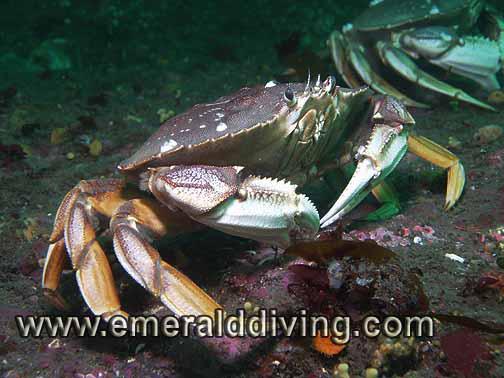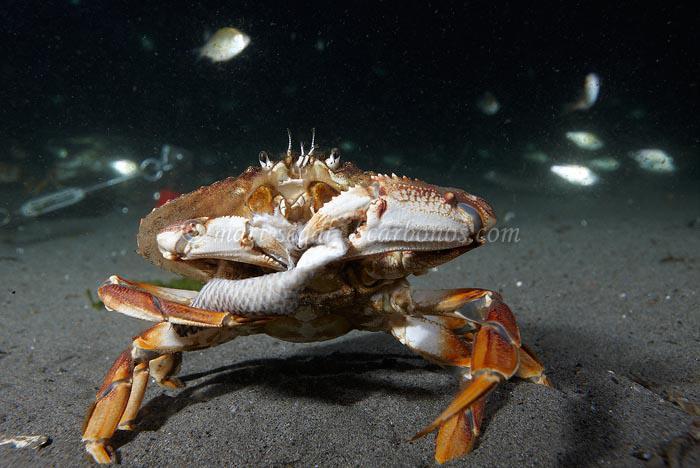The first image is the image on the left, the second image is the image on the right. Considering the images on both sides, is "there are two crabs in the image pair" valid? Answer yes or no. No. 